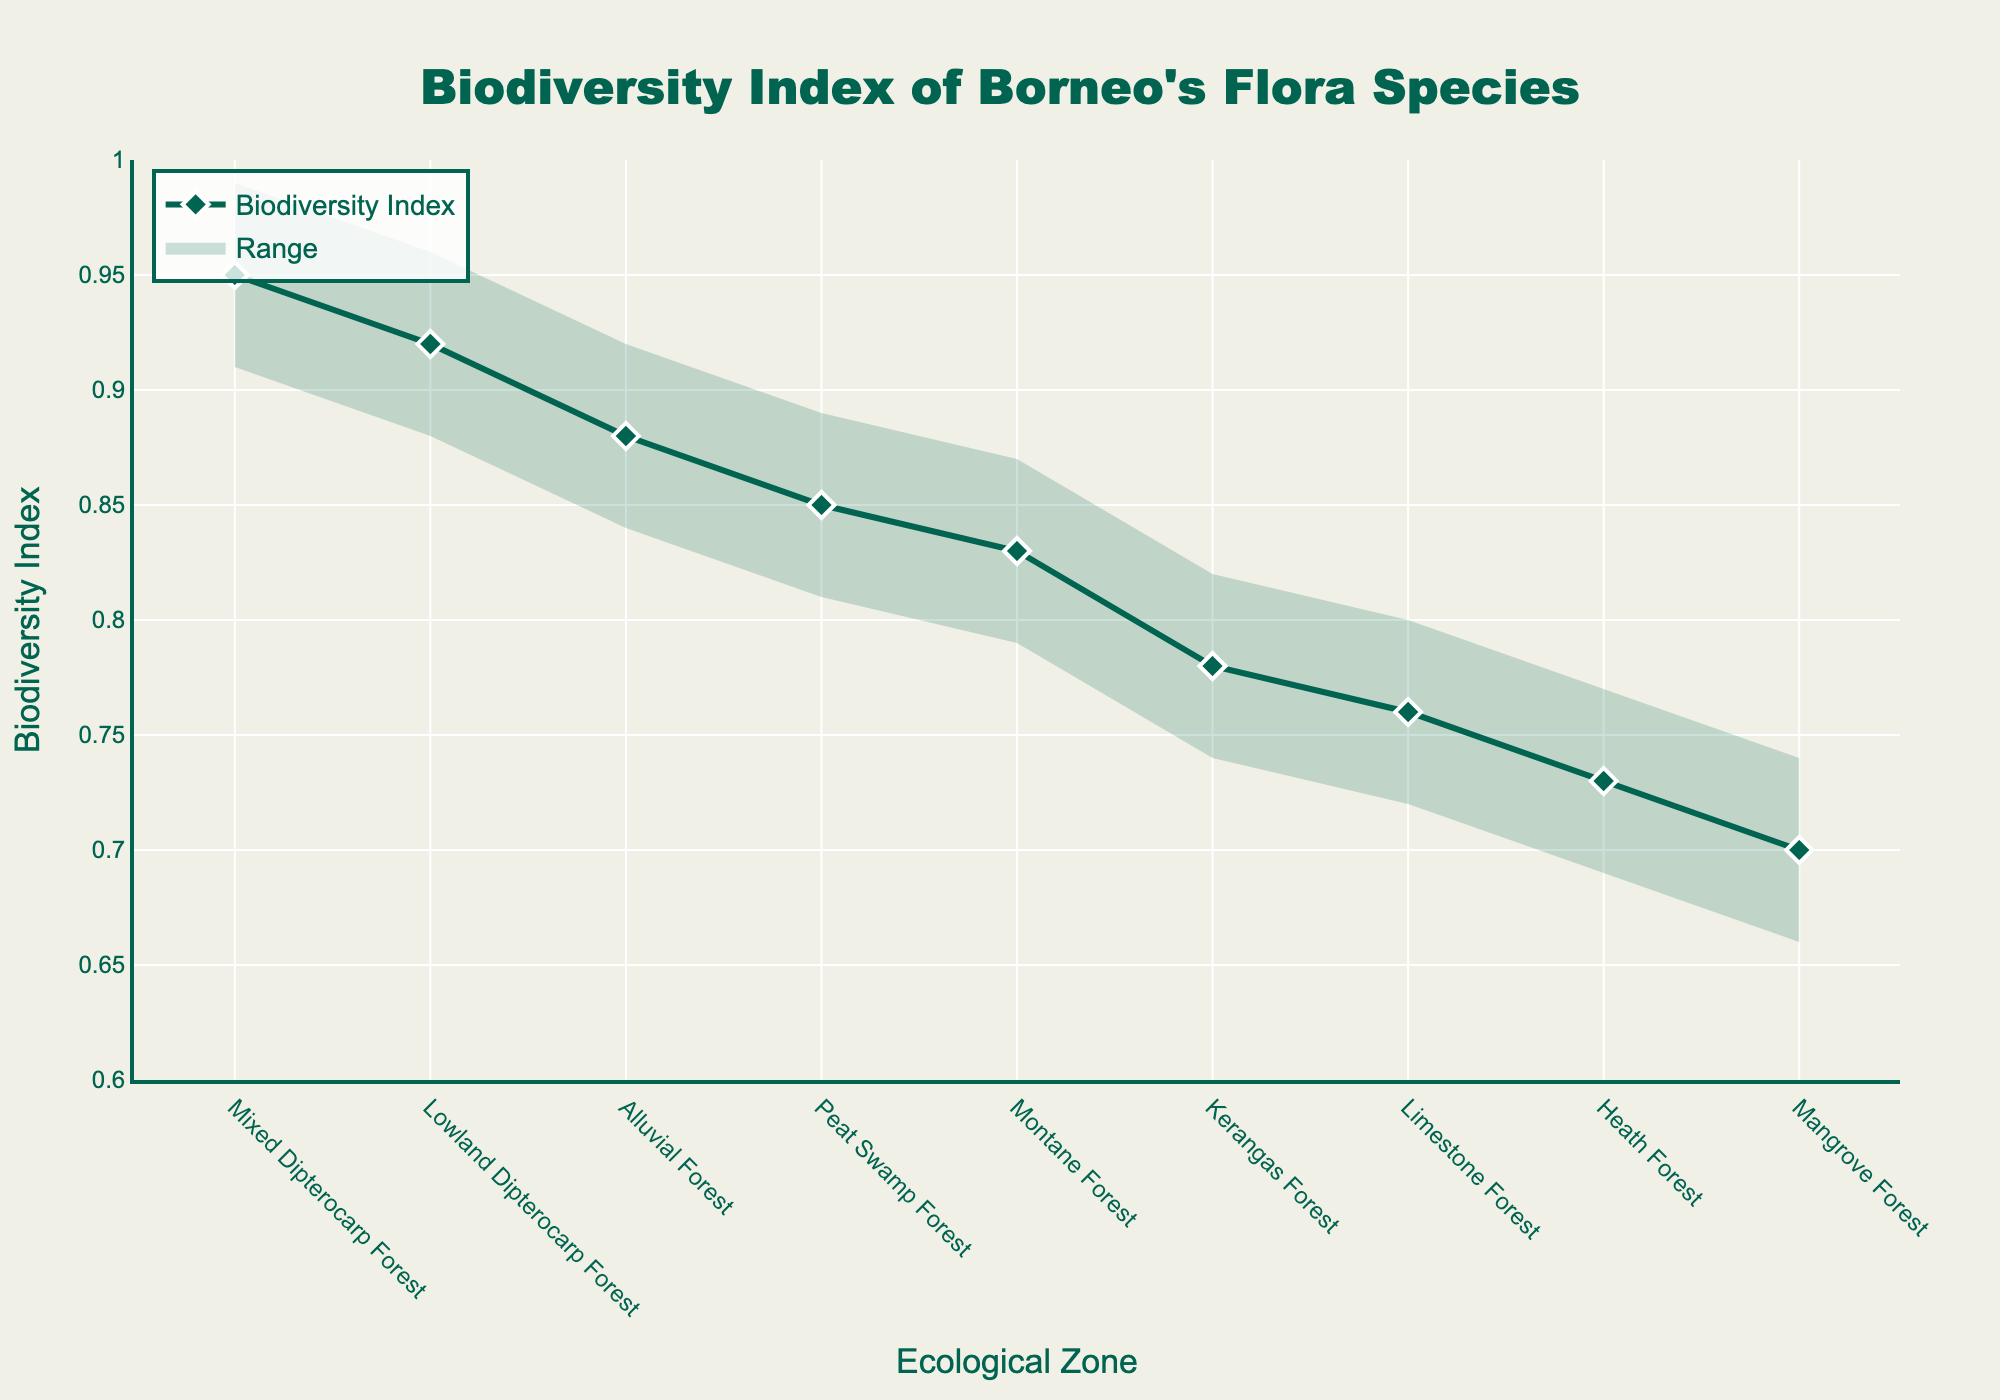What is the title of this chart? The title is typically written at the top of the chart and often provides a summary of what the chart is about. In this case, it says "Biodiversity Index of Borneo's Flora Species".
Answer: Biodiversity Index of Borneo's Flora Species Which ecological zone has the highest biodiversity index? The highest biodiversity index can be identified by looking at the topmost point on the line representing the 'Biodiversity Index'. The Mixed Dipterocarp Forest has the highest value on that line.
Answer: Mixed Dipterocarp Forest What is the biodiversity index of the Mangrove Forest? The biodiversity index of each ecological zone can be identified by looking at the data points on the line representing 'Biodiversity Index'. The position of the Mangrove Forest on this line indicates its biodiversity index.
Answer: 0.70 What are the upper and lower range values for the Limestone Forest? The fan chart shows the upper and lower range values as two lines encompassing the area in which the actual biodiversity index can vary. For the Limestone Forest, these values can be directly seen in this band.
Answer: 0.72 (lower), 0.80 (upper) Which ecological zone has a lower range that exceeds the upper range of the Mangrove Forest? By comparing the lower range of each ecological zone with the upper range of the Mangrove Forest, we can identify that the Lowland Dipterocarp Forest, Alluvial Forest, Mixed Dipterocarp Forest, Montane Forest, and Peat Swamp Forest have lower range values higher than the highest value for the Mangrove Forest.
Answer: Lowland Dipterocarp Forest, Alluvial Forest, Mixed Dipterocarp Forest, Montane Forest, Peat Swamp Forest What is the difference between the biodiversity index of the Lowland Dipterocarp Forest and Heath Forest? To find the difference, subtract the biodiversity index value of the Heath Forest from that of the Lowland Dipterocarp Forest. This can be seen by locating these indices on the line representation and performing the subtraction.
Answer: 0.19 (0.92 - 0.73) How many ecological zones have a biodiversity index of 0.85 or higher? To answer this, count the data points on the 'Biodiversity Index' line that have values greater than or equal to 0.85. The zones meeting this criterion are Lowland Dipterocarp Forest, Peat Swamp Forest, Montane Forest, Alluvial Forest, and Mixed Dipterocarp Forest.
Answer: 5 Which ecological zone shows the most considerable uncertainty in its biodiversity index (widest range)? The range is the difference between the upper and lower values, and the zone with the most considerable difference indicates the most uncertainty. You can calculate the range for each zone and compare them.
Answer: Mangrove Forest Does the Kerangas Forest have a higher biodiversity index than the Limestone Forest? By comparing the heights of the data points on the line representing 'Biodiversity Index', we can see that the Kerangas Forest has a higher biodiversity index than the Limestone Forest.
Answer: Yes 